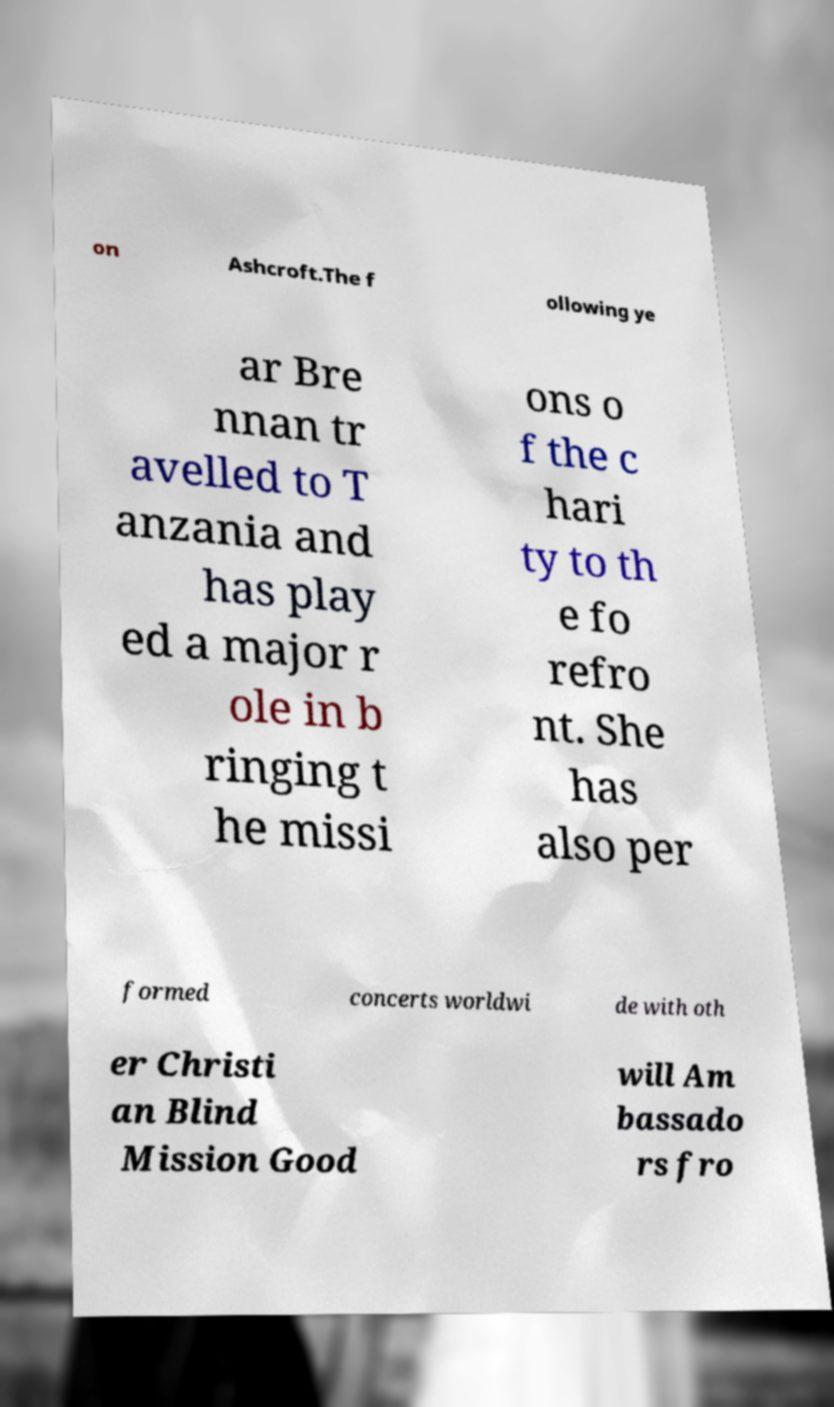Can you read and provide the text displayed in the image?This photo seems to have some interesting text. Can you extract and type it out for me? on Ashcroft.The f ollowing ye ar Bre nnan tr avelled to T anzania and has play ed a major r ole in b ringing t he missi ons o f the c hari ty to th e fo refro nt. She has also per formed concerts worldwi de with oth er Christi an Blind Mission Good will Am bassado rs fro 